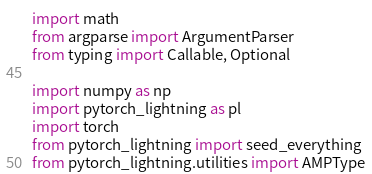Convert code to text. <code><loc_0><loc_0><loc_500><loc_500><_Python_>import math
from argparse import ArgumentParser
from typing import Callable, Optional

import numpy as np
import pytorch_lightning as pl
import torch
from pytorch_lightning import seed_everything
from pytorch_lightning.utilities import AMPType</code> 